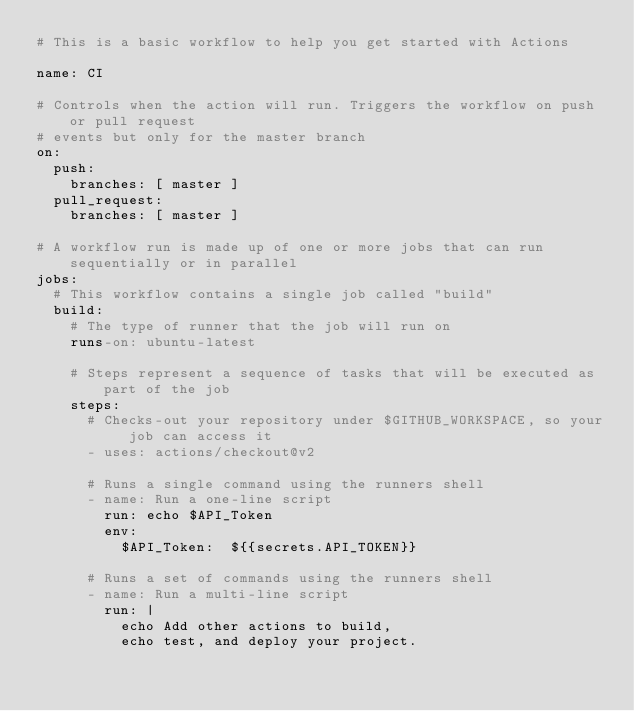<code> <loc_0><loc_0><loc_500><loc_500><_YAML_># This is a basic workflow to help you get started with Actions

name: CI

# Controls when the action will run. Triggers the workflow on push or pull request
# events but only for the master branch
on:
  push:
    branches: [ master ]
  pull_request:
    branches: [ master ]

# A workflow run is made up of one or more jobs that can run sequentially or in parallel
jobs:
  # This workflow contains a single job called "build"
  build:
    # The type of runner that the job will run on
    runs-on: ubuntu-latest

    # Steps represent a sequence of tasks that will be executed as part of the job
    steps:
      # Checks-out your repository under $GITHUB_WORKSPACE, so your job can access it
      - uses: actions/checkout@v2

      # Runs a single command using the runners shell
      - name: Run a one-line script
        run: echo $API_Token
        env:
          $API_Token:  ${{secrets.API_TOKEN}}

      # Runs a set of commands using the runners shell
      - name: Run a multi-line script
        run: |
          echo Add other actions to build,
          echo test, and deploy your project.
</code> 